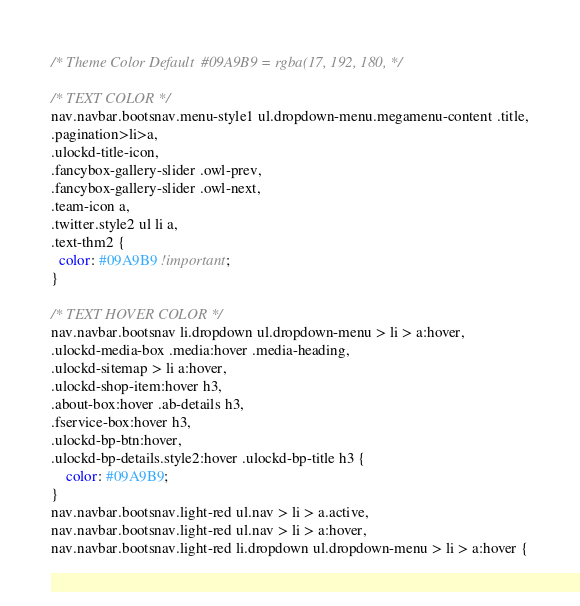Convert code to text. <code><loc_0><loc_0><loc_500><loc_500><_CSS_>/* Theme Color Default  #09A9B9 = rgba(17, 192, 180, */

/* TEXT COLOR */
nav.navbar.bootsnav.menu-style1 ul.dropdown-menu.megamenu-content .title,
.pagination>li>a,
.ulockd-title-icon,
.fancybox-gallery-slider .owl-prev,
.fancybox-gallery-slider .owl-next,
.team-icon a,
.twitter.style2 ul li a,
.text-thm2 {
  color: #09A9B9 !important;
}

/* TEXT HOVER COLOR */
nav.navbar.bootsnav li.dropdown ul.dropdown-menu > li > a:hover, 
.ulockd-media-box .media:hover .media-heading,
.ulockd-sitemap > li a:hover,
.ulockd-shop-item:hover h3,
.about-box:hover .ab-details h3,
.fservice-box:hover h3,
.ulockd-bp-btn:hover,
.ulockd-bp-details.style2:hover .ulockd-bp-title h3 {
	color: #09A9B9;
}
nav.navbar.bootsnav.light-red ul.nav > li > a.active,
nav.navbar.bootsnav.light-red ul.nav > li > a:hover,
nav.navbar.bootsnav.light-red li.dropdown ul.dropdown-menu > li > a:hover {</code> 